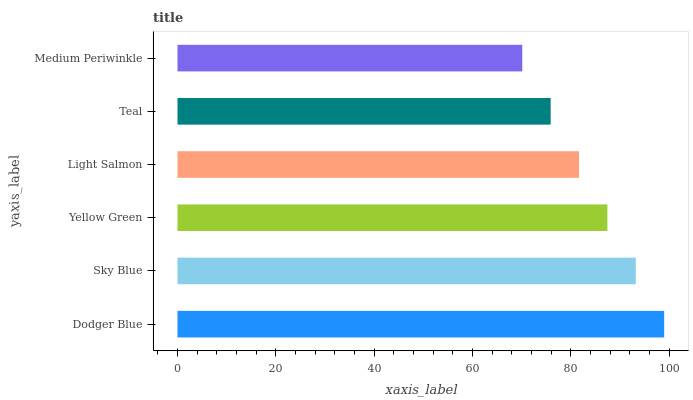Is Medium Periwinkle the minimum?
Answer yes or no. Yes. Is Dodger Blue the maximum?
Answer yes or no. Yes. Is Sky Blue the minimum?
Answer yes or no. No. Is Sky Blue the maximum?
Answer yes or no. No. Is Dodger Blue greater than Sky Blue?
Answer yes or no. Yes. Is Sky Blue less than Dodger Blue?
Answer yes or no. Yes. Is Sky Blue greater than Dodger Blue?
Answer yes or no. No. Is Dodger Blue less than Sky Blue?
Answer yes or no. No. Is Yellow Green the high median?
Answer yes or no. Yes. Is Light Salmon the low median?
Answer yes or no. Yes. Is Light Salmon the high median?
Answer yes or no. No. Is Medium Periwinkle the low median?
Answer yes or no. No. 